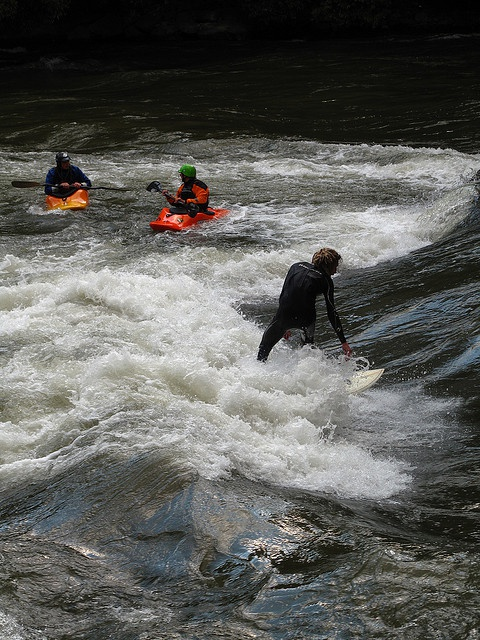Describe the objects in this image and their specific colors. I can see people in black, gray, darkgray, and maroon tones, people in black, maroon, and darkgreen tones, people in black, gray, maroon, and brown tones, boat in black, brown, maroon, red, and salmon tones, and surfboard in black, darkgray, lightgray, and gray tones in this image. 